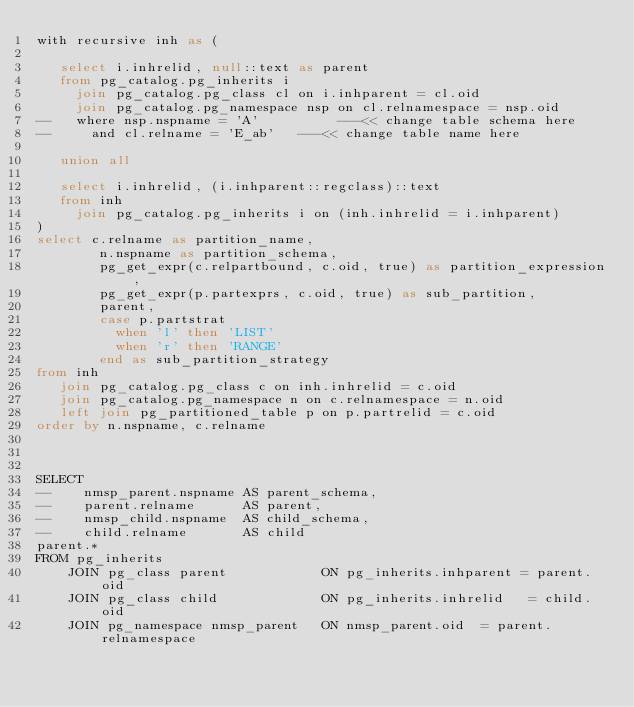Convert code to text. <code><loc_0><loc_0><loc_500><loc_500><_SQL_>with recursive inh as (

   select i.inhrelid, null::text as parent
   from pg_catalog.pg_inherits i
     join pg_catalog.pg_class cl on i.inhparent = cl.oid
     join pg_catalog.pg_namespace nsp on cl.relnamespace = nsp.oid
--   where nsp.nspname = 'A'          ---<< change table schema here
--     and cl.relname = 'E_ab'   ---<< change table name here

   union all

   select i.inhrelid, (i.inhparent::regclass)::text
   from inh
     join pg_catalog.pg_inherits i on (inh.inhrelid = i.inhparent)
)
select c.relname as partition_name,
        n.nspname as partition_schema,
        pg_get_expr(c.relpartbound, c.oid, true) as partition_expression,
        pg_get_expr(p.partexprs, c.oid, true) as sub_partition,
        parent,
        case p.partstrat
          when 'l' then 'LIST'
          when 'r' then 'RANGE'
        end as sub_partition_strategy
from inh
   join pg_catalog.pg_class c on inh.inhrelid = c.oid
   join pg_catalog.pg_namespace n on c.relnamespace = n.oid
   left join pg_partitioned_table p on p.partrelid = c.oid
order by n.nspname, c.relname



SELECT
--    nmsp_parent.nspname AS parent_schema,
--    parent.relname      AS parent,
--    nmsp_child.nspname  AS child_schema,
--    child.relname       AS child
parent.*
FROM pg_inherits
    JOIN pg_class parent            ON pg_inherits.inhparent = parent.oid
    JOIN pg_class child             ON pg_inherits.inhrelid   = child.oid
    JOIN pg_namespace nmsp_parent   ON nmsp_parent.oid  = parent.relnamespace</code> 